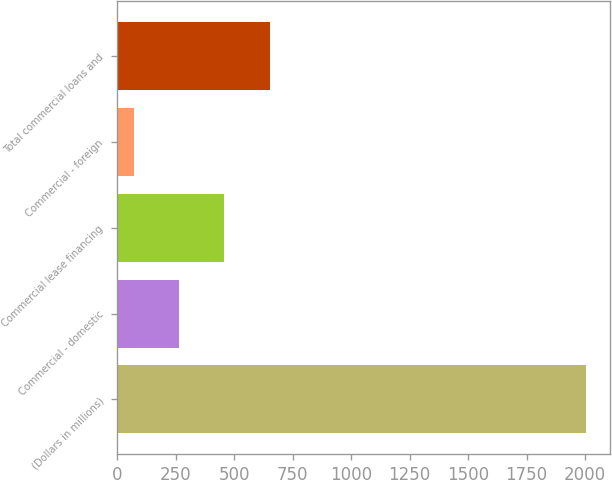<chart> <loc_0><loc_0><loc_500><loc_500><bar_chart><fcel>(Dollars in millions)<fcel>Commercial - domestic<fcel>Commercial lease financing<fcel>Commercial - foreign<fcel>Total commercial loans and<nl><fcel>2005<fcel>265.3<fcel>458.6<fcel>72<fcel>651.9<nl></chart> 